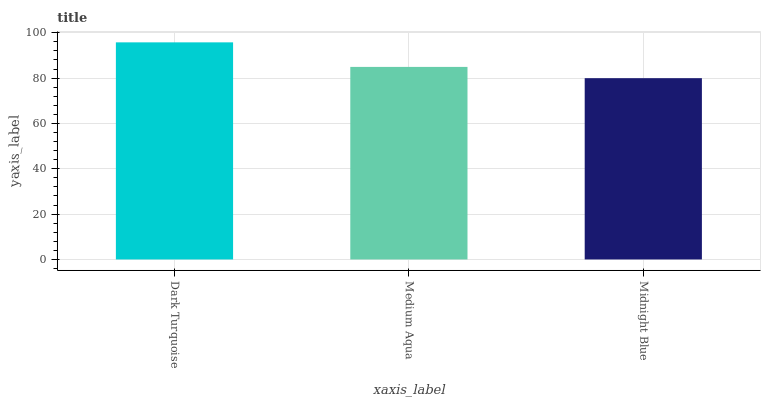Is Midnight Blue the minimum?
Answer yes or no. Yes. Is Dark Turquoise the maximum?
Answer yes or no. Yes. Is Medium Aqua the minimum?
Answer yes or no. No. Is Medium Aqua the maximum?
Answer yes or no. No. Is Dark Turquoise greater than Medium Aqua?
Answer yes or no. Yes. Is Medium Aqua less than Dark Turquoise?
Answer yes or no. Yes. Is Medium Aqua greater than Dark Turquoise?
Answer yes or no. No. Is Dark Turquoise less than Medium Aqua?
Answer yes or no. No. Is Medium Aqua the high median?
Answer yes or no. Yes. Is Medium Aqua the low median?
Answer yes or no. Yes. Is Midnight Blue the high median?
Answer yes or no. No. Is Dark Turquoise the low median?
Answer yes or no. No. 